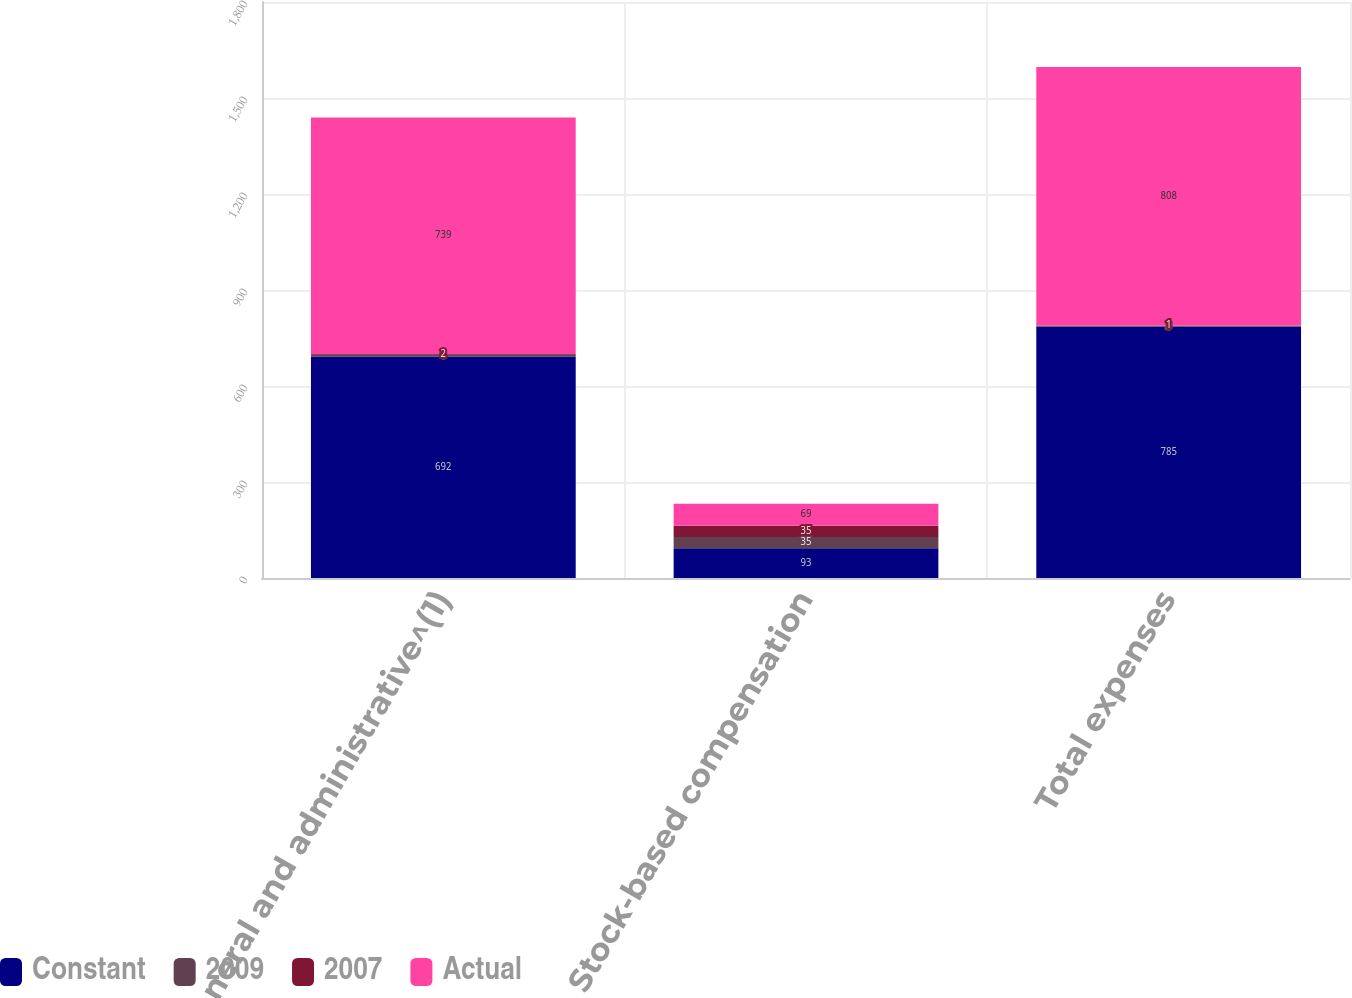<chart> <loc_0><loc_0><loc_500><loc_500><stacked_bar_chart><ecel><fcel>General and administrative^(1)<fcel>Stock-based compensation<fcel>Total expenses<nl><fcel>Constant<fcel>692<fcel>93<fcel>785<nl><fcel>2009<fcel>6<fcel>35<fcel>3<nl><fcel>2007<fcel>2<fcel>35<fcel>1<nl><fcel>Actual<fcel>739<fcel>69<fcel>808<nl></chart> 